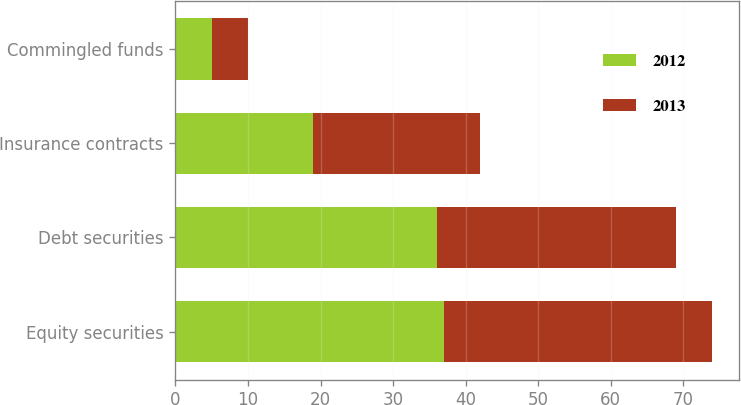<chart> <loc_0><loc_0><loc_500><loc_500><stacked_bar_chart><ecel><fcel>Equity securities<fcel>Debt securities<fcel>Insurance contracts<fcel>Commingled funds<nl><fcel>2012<fcel>37<fcel>36<fcel>19<fcel>5<nl><fcel>2013<fcel>37<fcel>33<fcel>23<fcel>5<nl></chart> 